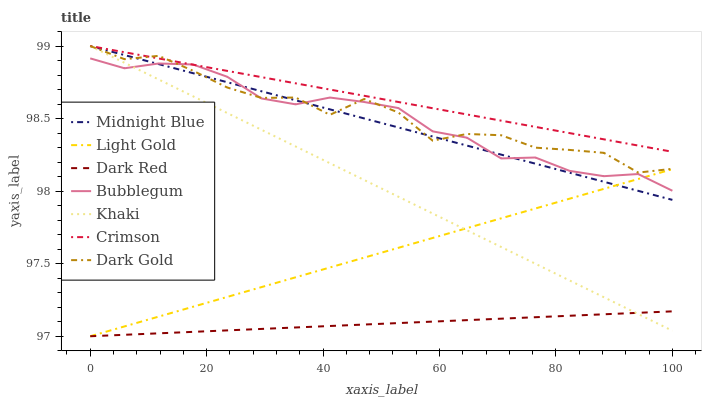Does Dark Red have the minimum area under the curve?
Answer yes or no. Yes. Does Crimson have the maximum area under the curve?
Answer yes or no. Yes. Does Midnight Blue have the minimum area under the curve?
Answer yes or no. No. Does Midnight Blue have the maximum area under the curve?
Answer yes or no. No. Is Midnight Blue the smoothest?
Answer yes or no. Yes. Is Dark Gold the roughest?
Answer yes or no. Yes. Is Dark Gold the smoothest?
Answer yes or no. No. Is Midnight Blue the roughest?
Answer yes or no. No. Does Midnight Blue have the lowest value?
Answer yes or no. No. Does Dark Red have the highest value?
Answer yes or no. No. Is Dark Red less than Crimson?
Answer yes or no. Yes. Is Dark Gold greater than Light Gold?
Answer yes or no. Yes. Does Dark Red intersect Crimson?
Answer yes or no. No. 